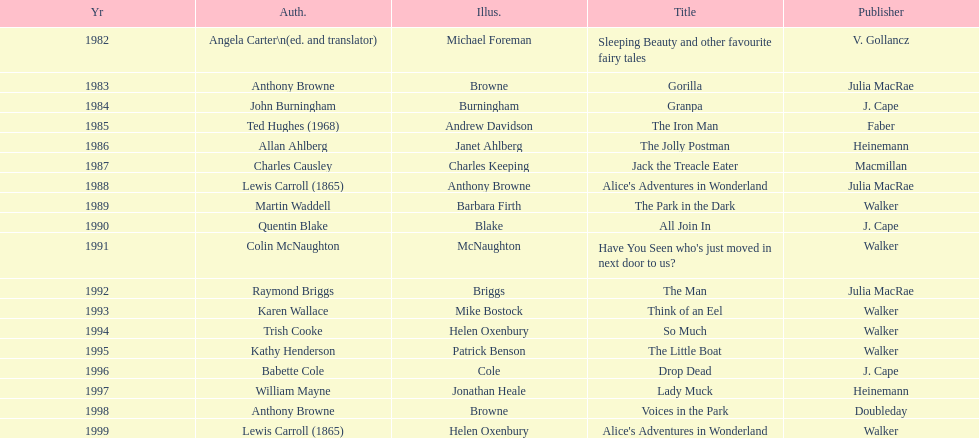Which other author, besides lewis carroll, has won the kurt maschler award twice? Anthony Browne. 